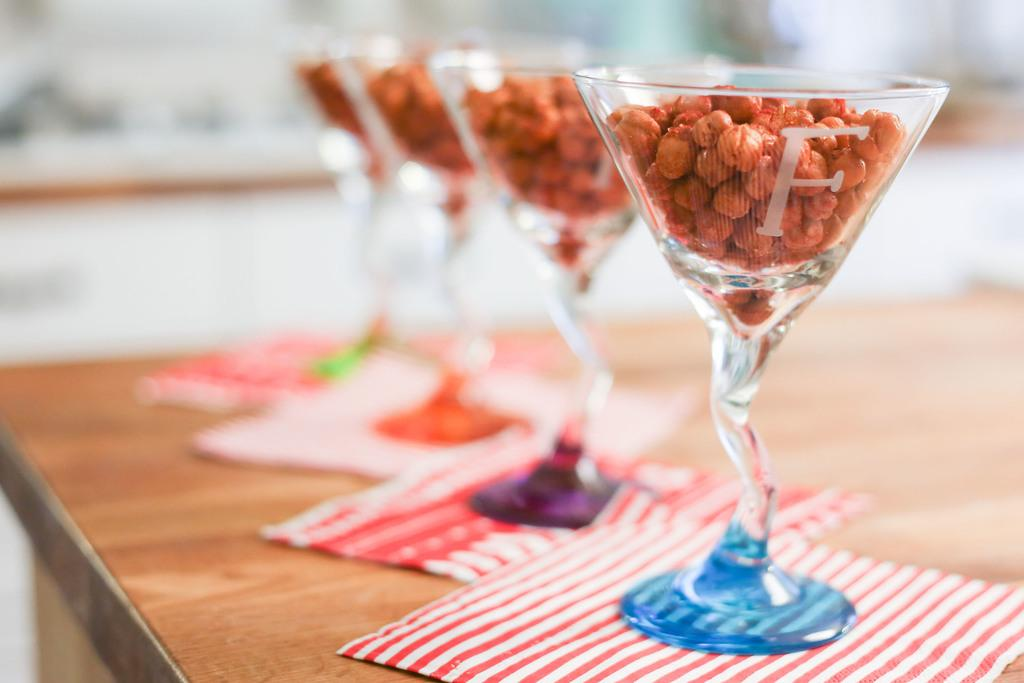What objects are present on the table in the image? There are tissue papers and wine glasses on the table. Are there any other items visible on the table? Yes, there are seeds on the table. What can be seen in the background of the image? There is a white color wall in the background. How many sugar cubes are on the table in the image? There is no mention of sugar cubes in the image, so we cannot determine their presence or quantity. Can you see an aunt in the image? There is no reference to an aunt in the image, so we cannot confirm her presence. 